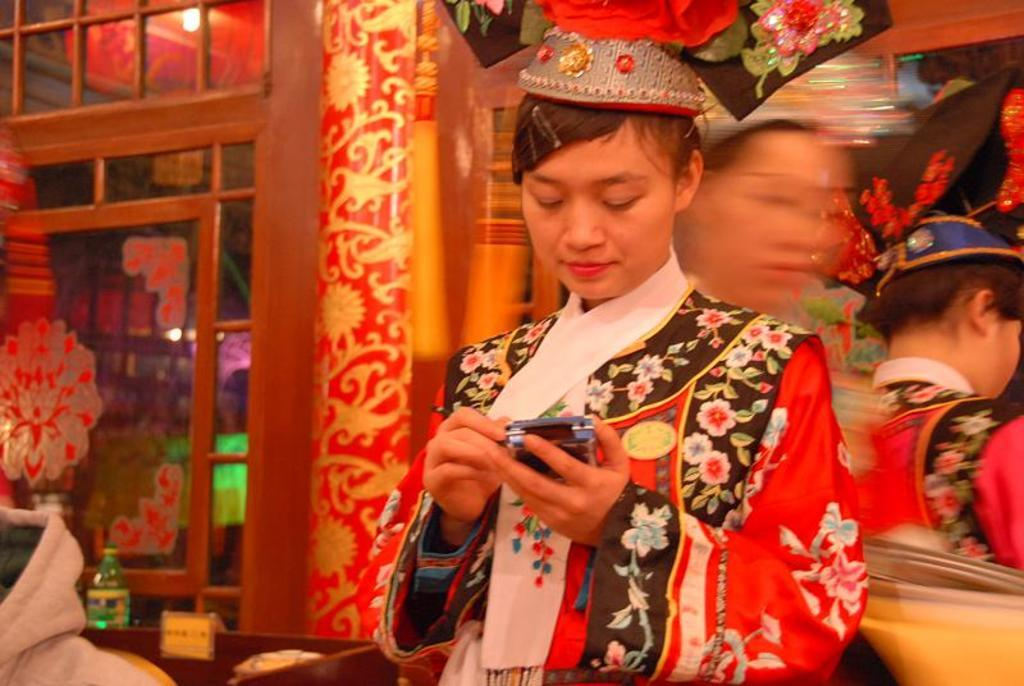How many people are in the image? There are three persons in the image. What object can be seen in the image that people might sit on? There is a bench in the image. What object can be seen in the image that people might drink from? There is a bottle in the image. What object can be seen in the image that people might use to enter or exit a room? There is a door in the image. What objects can be seen in the image that provide illumination? There are lights in the image. Can you describe the possible setting of the image? The image may have been taken in a hall. What type of ink can be seen on the locket in the image? There is no locket present in the image, so it is not possible to determine if there is any ink on it. 